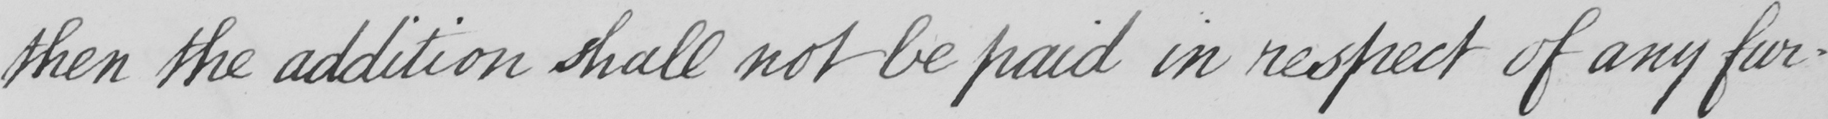What is written in this line of handwriting? then the addition shall not be paid in respect of any fur- 